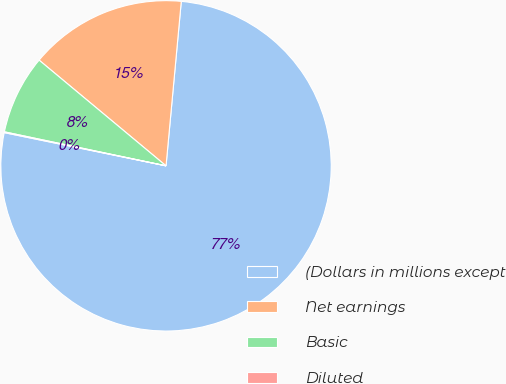Convert chart. <chart><loc_0><loc_0><loc_500><loc_500><pie_chart><fcel>(Dollars in millions except<fcel>Net earnings<fcel>Basic<fcel>Diluted<nl><fcel>76.75%<fcel>15.42%<fcel>7.75%<fcel>0.08%<nl></chart> 